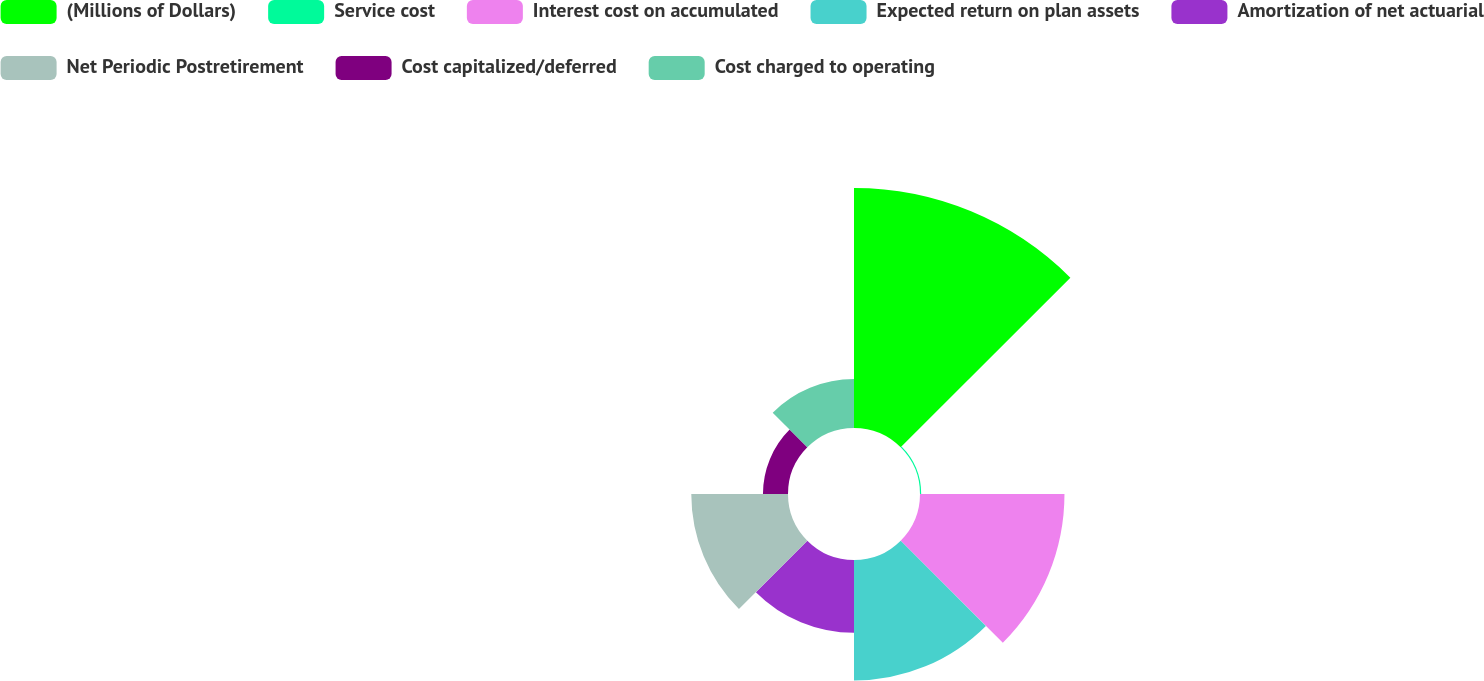Convert chart to OTSL. <chart><loc_0><loc_0><loc_500><loc_500><pie_chart><fcel>(Millions of Dollars)<fcel>Service cost<fcel>Interest cost on accumulated<fcel>Expected return on plan assets<fcel>Amortization of net actuarial<fcel>Net Periodic Postretirement<fcel>Cost capitalized/deferred<fcel>Cost charged to operating<nl><fcel>32.01%<fcel>0.16%<fcel>19.27%<fcel>16.08%<fcel>9.71%<fcel>12.9%<fcel>3.34%<fcel>6.53%<nl></chart> 